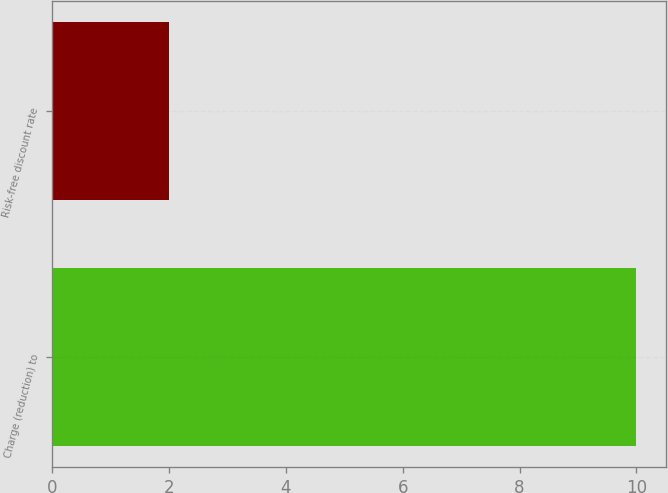<chart> <loc_0><loc_0><loc_500><loc_500><bar_chart><fcel>Charge (reduction) to<fcel>Risk-free discount rate<nl><fcel>10<fcel>2<nl></chart> 